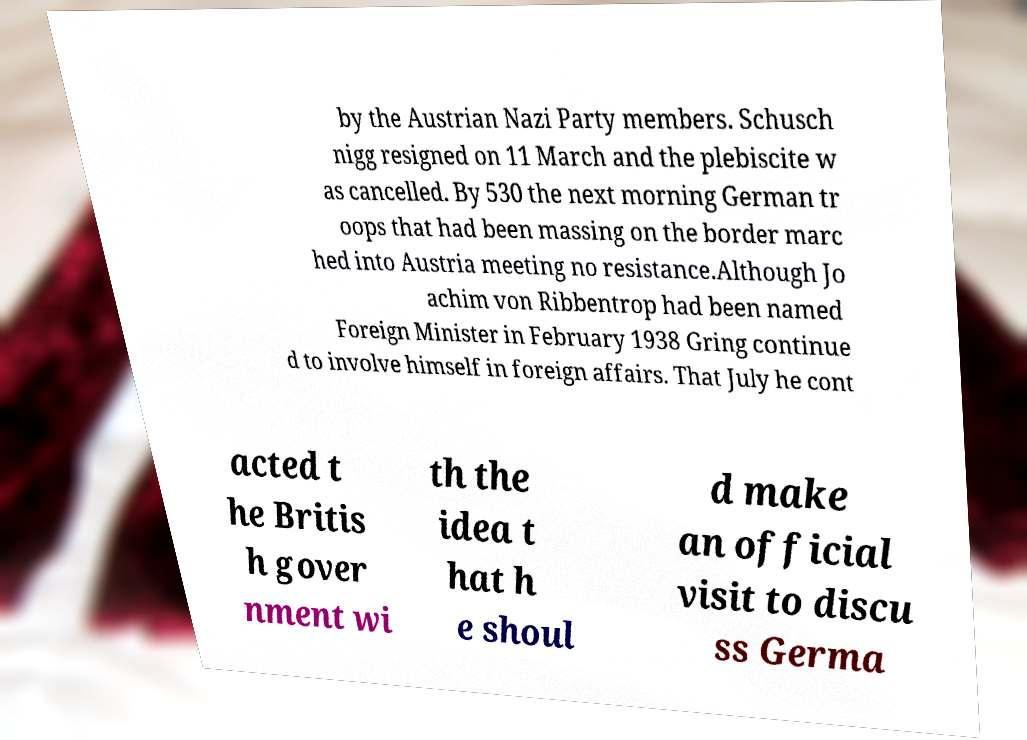There's text embedded in this image that I need extracted. Can you transcribe it verbatim? by the Austrian Nazi Party members. Schusch nigg resigned on 11 March and the plebiscite w as cancelled. By 530 the next morning German tr oops that had been massing on the border marc hed into Austria meeting no resistance.Although Jo achim von Ribbentrop had been named Foreign Minister in February 1938 Gring continue d to involve himself in foreign affairs. That July he cont acted t he Britis h gover nment wi th the idea t hat h e shoul d make an official visit to discu ss Germa 